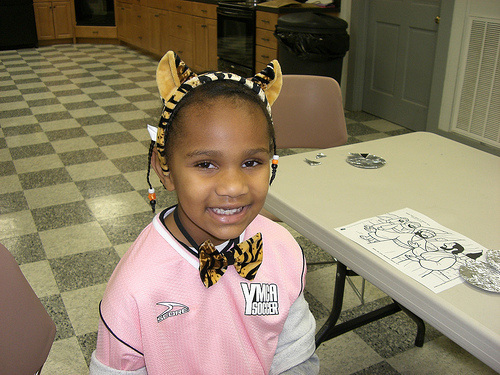<image>
Is the girl to the right of the table? No. The girl is not to the right of the table. The horizontal positioning shows a different relationship. 